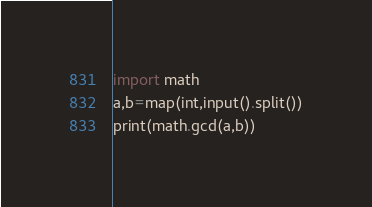Convert code to text. <code><loc_0><loc_0><loc_500><loc_500><_Python_>import math
a,b=map(int,input().split())
print(math.gcd(a,b))
</code> 